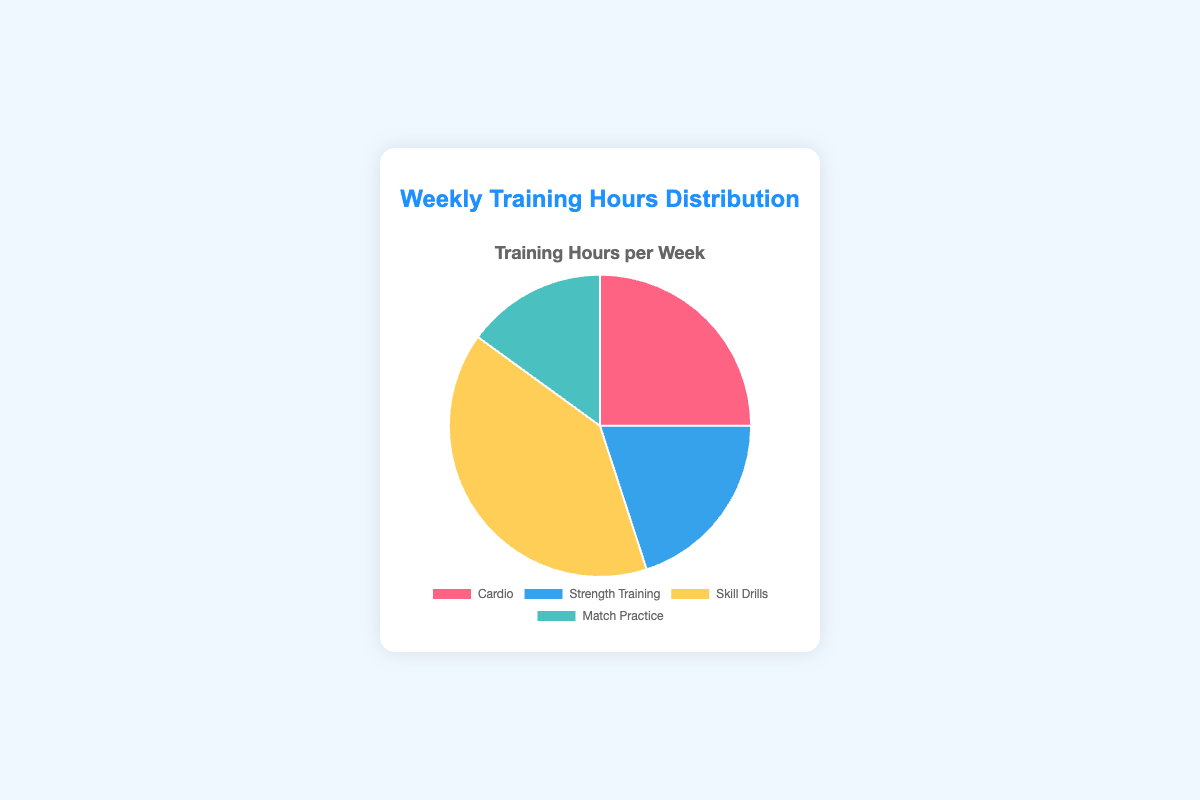Which type of workout has the highest number of training hours? The pie chart shows four categories, and the slice labeled "Skill Drills" is the largest in size. Therefore, "Skill Drills" has the highest number of training hours.
Answer: Skill Drills Which type of workout has the smallest number of training hours? By comparing the sizes of the slices in the pie chart, the slice labeled "Match Practice" is the smallest, indicating it has the least number of training hours.
Answer: Match Practice How many total hours are spent on cardio and strength training combined? According to the data points provided, cardio has 5 hours and strength training has 4 hours. Adding these together, 5 + 4 = 9 hours.
Answer: 9 How much more time is spent on skill drills compared to match practice? Skill drills account for 8 hours, and match practice covers 3 hours. The difference is 8 - 3 = 5 hours.
Answer: 5 What percentage of the total training hours is devoted to cardio? The total number of hours is the sum of all the training hours: 5 (Cardio) + 4 (Strength Training) + 8 (Skill Drills) + 3 (Match Practice) = 20 hours. The percentage for cardio is (5/20) * 100% = 25%.
Answer: 25% Which slice on the chart represents match practice hours? The pie chart includes sections in different colors. The smallest slice of the pie chart, representing 3 hours, is colored differently from the other slices. This slice represents match practice hours.
Answer: The smallest slice What is the ratio of hours spent on skill drills to the hours spent on cardio? Skill drills have 8 hours, and cardio has 5 hours. The ratio of hours spent is 8:5.
Answer: 8:5 If 2 more hours were added to strength training, what would be the new total number of training hours? The current total is 20 hours. Adding 2 more hours to the current 4 hours of strength training results in 4 + 2 = 6 hours. Therefore, the new total is 20 + 2 = 22 hours.
Answer: 22 What percentage of the total training hours is spent on skill drills and match practice combined? The total training hours are obtained by summing: 5 + 4 + 8 + 3 = 20 hours. Combining skill drills and match practice gives 8 (Skill Drills) + 3 (Match Practice) = 11 hours. The percentage is (11/20) * 100% = 55%.
Answer: 55% How does the time spent on strength training compare to the combined time spent on match practice and cardio? Strength training has 4 hours, while the combined time for match practice and cardio is 3 (Match Practice) + 5 (Cardio) = 8 hours. Thus, 4 hours (Strength Training) < 8 hours (Match Practice + Cardio).
Answer: Less than 